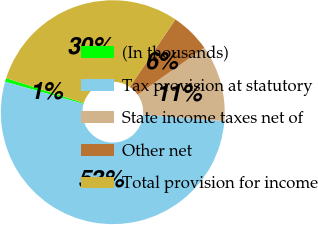<chart> <loc_0><loc_0><loc_500><loc_500><pie_chart><fcel>(In thousands)<fcel>Tax provision at statutory<fcel>State income taxes net of<fcel>Other net<fcel>Total provision for income<nl><fcel>0.53%<fcel>53.11%<fcel>11.05%<fcel>5.79%<fcel>29.53%<nl></chart> 